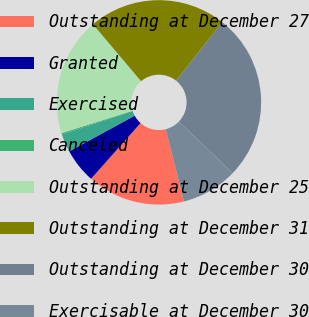Convert chart to OTSL. <chart><loc_0><loc_0><loc_500><loc_500><pie_chart><fcel>Outstanding at December 27<fcel>Granted<fcel>Exercised<fcel>Canceled<fcel>Outstanding at December 25<fcel>Outstanding at December 31<fcel>Outstanding at December 30<fcel>Exercisable at December 30<nl><fcel>15.5%<fcel>5.49%<fcel>2.86%<fcel>0.23%<fcel>18.71%<fcel>21.81%<fcel>26.52%<fcel>8.89%<nl></chart> 